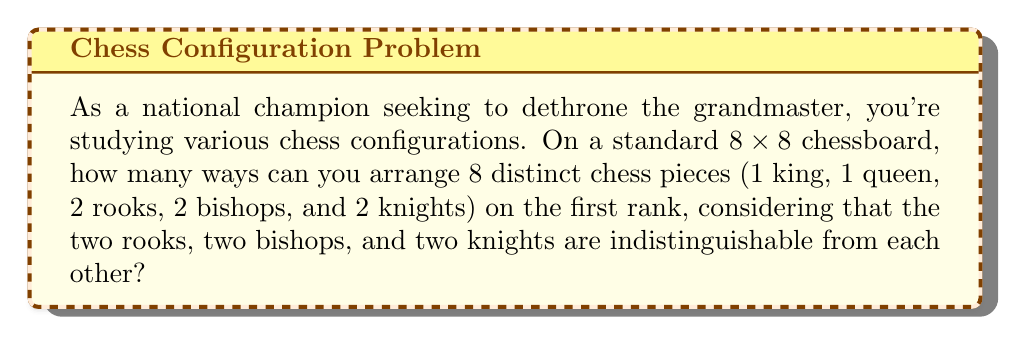Give your solution to this math problem. Let's approach this step-by-step:

1) We have 8 distinct positions on the first rank and 8 pieces to arrange.

2) However, some pieces are indistinguishable:
   - 2 rooks are identical
   - 2 bishops are identical
   - 2 knights are identical

3) This is a permutation problem with repeated elements. The formula for this is:

   $$\frac{n!}{n_1!n_2!...n_k!}$$

   Where $n$ is the total number of items, and $n_1, n_2, ..., n_k$ are the numbers of each type of repeated item.

4) In our case:
   $n = 8$ (total positions)
   $n_1 = 2$ (rooks)
   $n_2 = 2$ (bishops)
   $n_3 = 2$ (knights)

5) Applying the formula:

   $$\frac{8!}{2!2!2!} = \frac{40320}{8} = 5040$$

6) Therefore, there are 5040 ways to arrange these chess pieces on the first rank.

This calculation considers all possible arrangements, allowing you to study various opening configurations and potentially surprise the grandmaster with unconventional setups.
Answer: 5040 